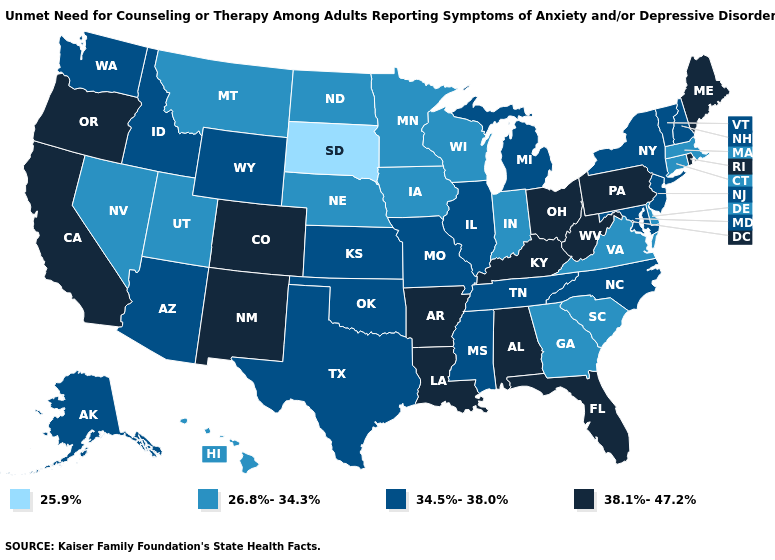Does Kentucky have the lowest value in the South?
Answer briefly. No. Name the states that have a value in the range 26.8%-34.3%?
Answer briefly. Connecticut, Delaware, Georgia, Hawaii, Indiana, Iowa, Massachusetts, Minnesota, Montana, Nebraska, Nevada, North Dakota, South Carolina, Utah, Virginia, Wisconsin. Name the states that have a value in the range 26.8%-34.3%?
Answer briefly. Connecticut, Delaware, Georgia, Hawaii, Indiana, Iowa, Massachusetts, Minnesota, Montana, Nebraska, Nevada, North Dakota, South Carolina, Utah, Virginia, Wisconsin. Among the states that border Oregon , does Nevada have the lowest value?
Write a very short answer. Yes. What is the value of New Hampshire?
Give a very brief answer. 34.5%-38.0%. Name the states that have a value in the range 25.9%?
Answer briefly. South Dakota. What is the value of New York?
Keep it brief. 34.5%-38.0%. Among the states that border Minnesota , does Wisconsin have the highest value?
Write a very short answer. Yes. What is the value of Virginia?
Keep it brief. 26.8%-34.3%. Among the states that border Oklahoma , does Arkansas have the highest value?
Answer briefly. Yes. Which states have the highest value in the USA?
Short answer required. Alabama, Arkansas, California, Colorado, Florida, Kentucky, Louisiana, Maine, New Mexico, Ohio, Oregon, Pennsylvania, Rhode Island, West Virginia. Which states hav the highest value in the West?
Answer briefly. California, Colorado, New Mexico, Oregon. Name the states that have a value in the range 34.5%-38.0%?
Write a very short answer. Alaska, Arizona, Idaho, Illinois, Kansas, Maryland, Michigan, Mississippi, Missouri, New Hampshire, New Jersey, New York, North Carolina, Oklahoma, Tennessee, Texas, Vermont, Washington, Wyoming. What is the value of Alaska?
Be succinct. 34.5%-38.0%. Does the first symbol in the legend represent the smallest category?
Concise answer only. Yes. 